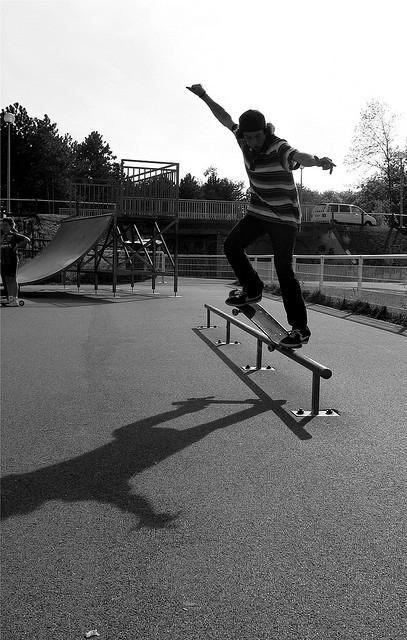Does the skater have the front of his board in the air?
Short answer required. No. What pattern shirt is the person wearing?
Quick response, please. Striped. Is the boy dancing?
Concise answer only. No. 